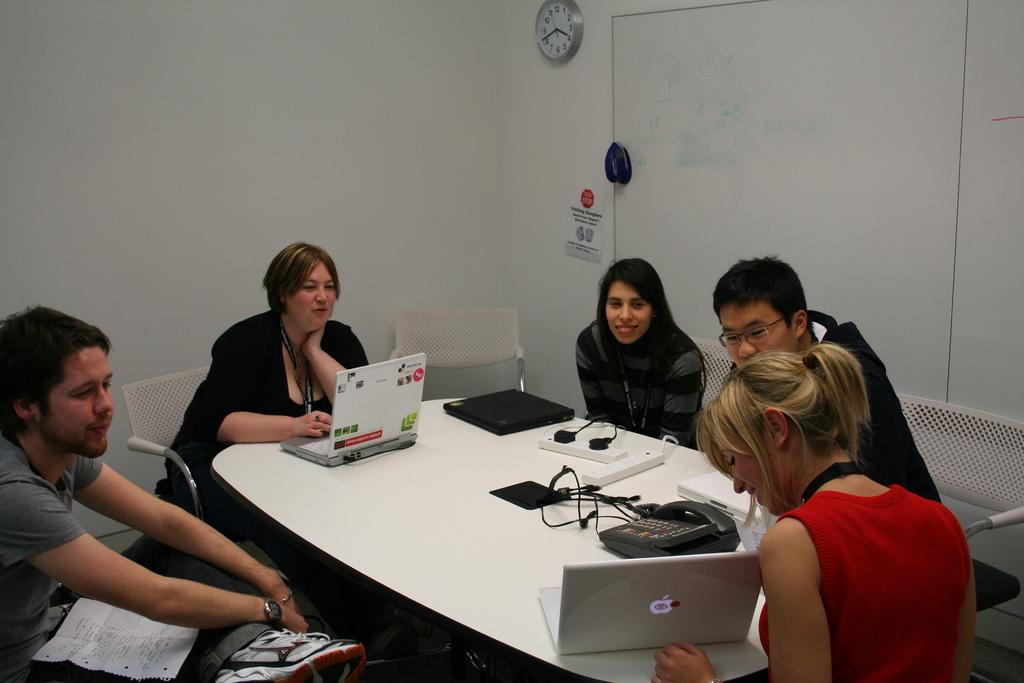What are the people in the image doing? There is a group of people sitting in front of a table. What objects can be seen on the table? There are laptops and a telephone on the table. Is there any time-related object in the image? Yes, there is a clock on the wall. What type of rake is being used by the people in the image? There is no rake present in the image; the people are sitting at a table with laptops and a telephone. What flavor of quince is being served at the table? There is no mention of quince or any food in the image; the focus is on the people, laptops, telephone, and clock. 